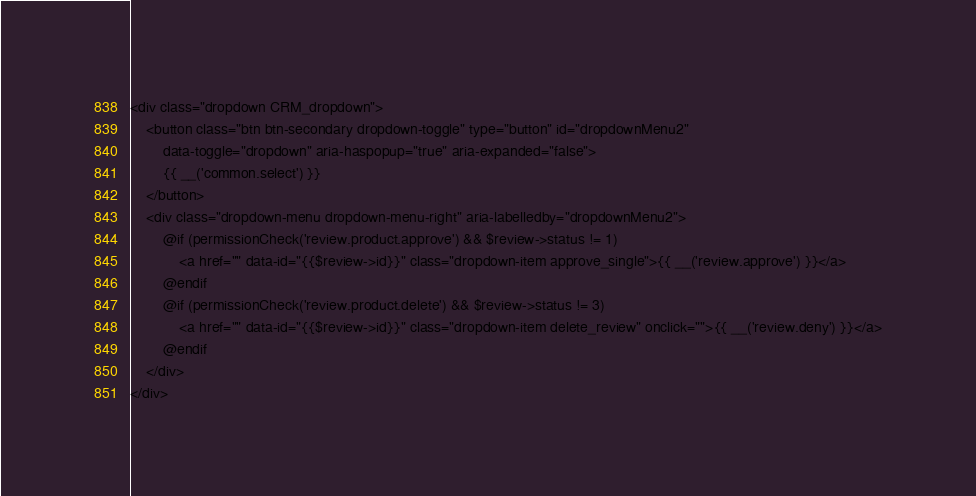<code> <loc_0><loc_0><loc_500><loc_500><_PHP_><div class="dropdown CRM_dropdown">
    <button class="btn btn-secondary dropdown-toggle" type="button" id="dropdownMenu2"
        data-toggle="dropdown" aria-haspopup="true" aria-expanded="false">
        {{ __('common.select') }}
    </button>
    <div class="dropdown-menu dropdown-menu-right" aria-labelledby="dropdownMenu2">
        @if (permissionCheck('review.product.approve') && $review->status != 1)
            <a href="" data-id="{{$review->id}}" class="dropdown-item approve_single">{{ __('review.approve') }}</a>
        @endif
        @if (permissionCheck('review.product.delete') && $review->status != 3)
            <a href="" data-id="{{$review->id}}" class="dropdown-item delete_review" onclick="">{{ __('review.deny') }}</a>
        @endif
    </div>
</div>
</code> 